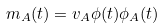Convert formula to latex. <formula><loc_0><loc_0><loc_500><loc_500>m _ { A } ( t ) = v _ { A } \phi ( t ) \phi _ { A } ( t )</formula> 